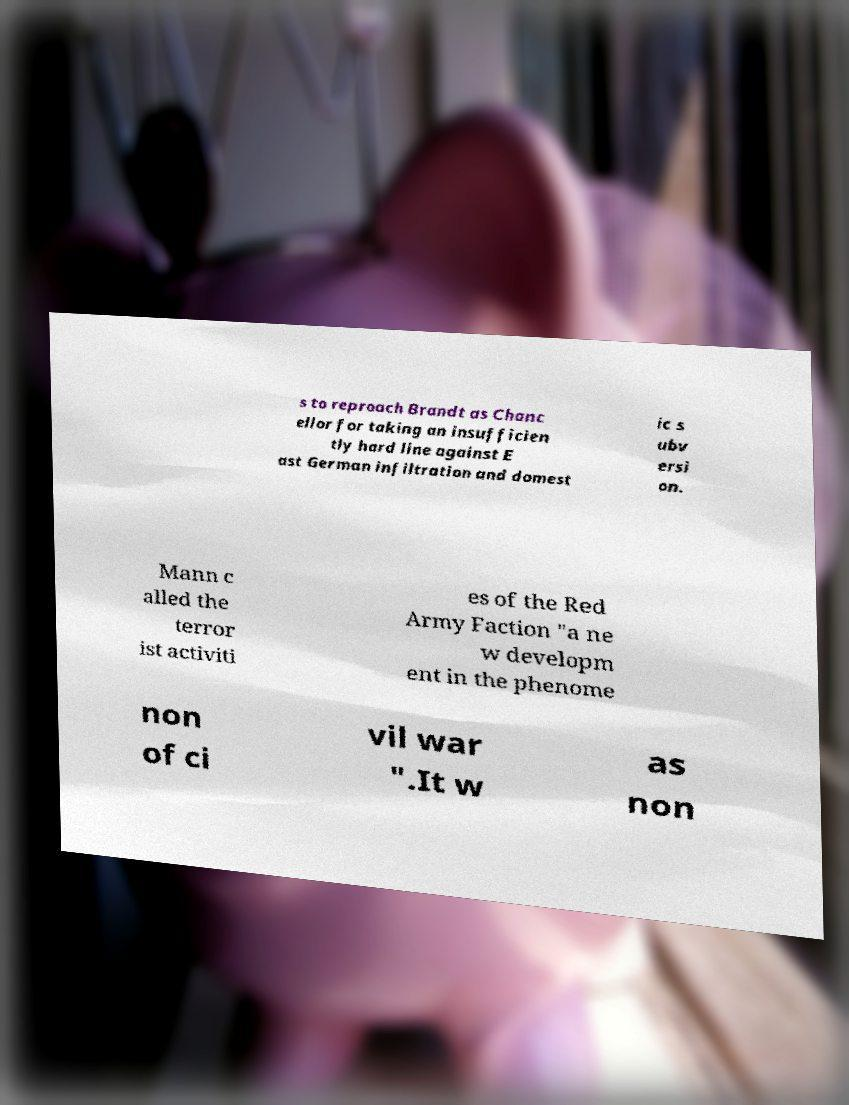Can you read and provide the text displayed in the image?This photo seems to have some interesting text. Can you extract and type it out for me? s to reproach Brandt as Chanc ellor for taking an insufficien tly hard line against E ast German infiltration and domest ic s ubv ersi on. Mann c alled the terror ist activiti es of the Red Army Faction "a ne w developm ent in the phenome non of ci vil war ".It w as non 